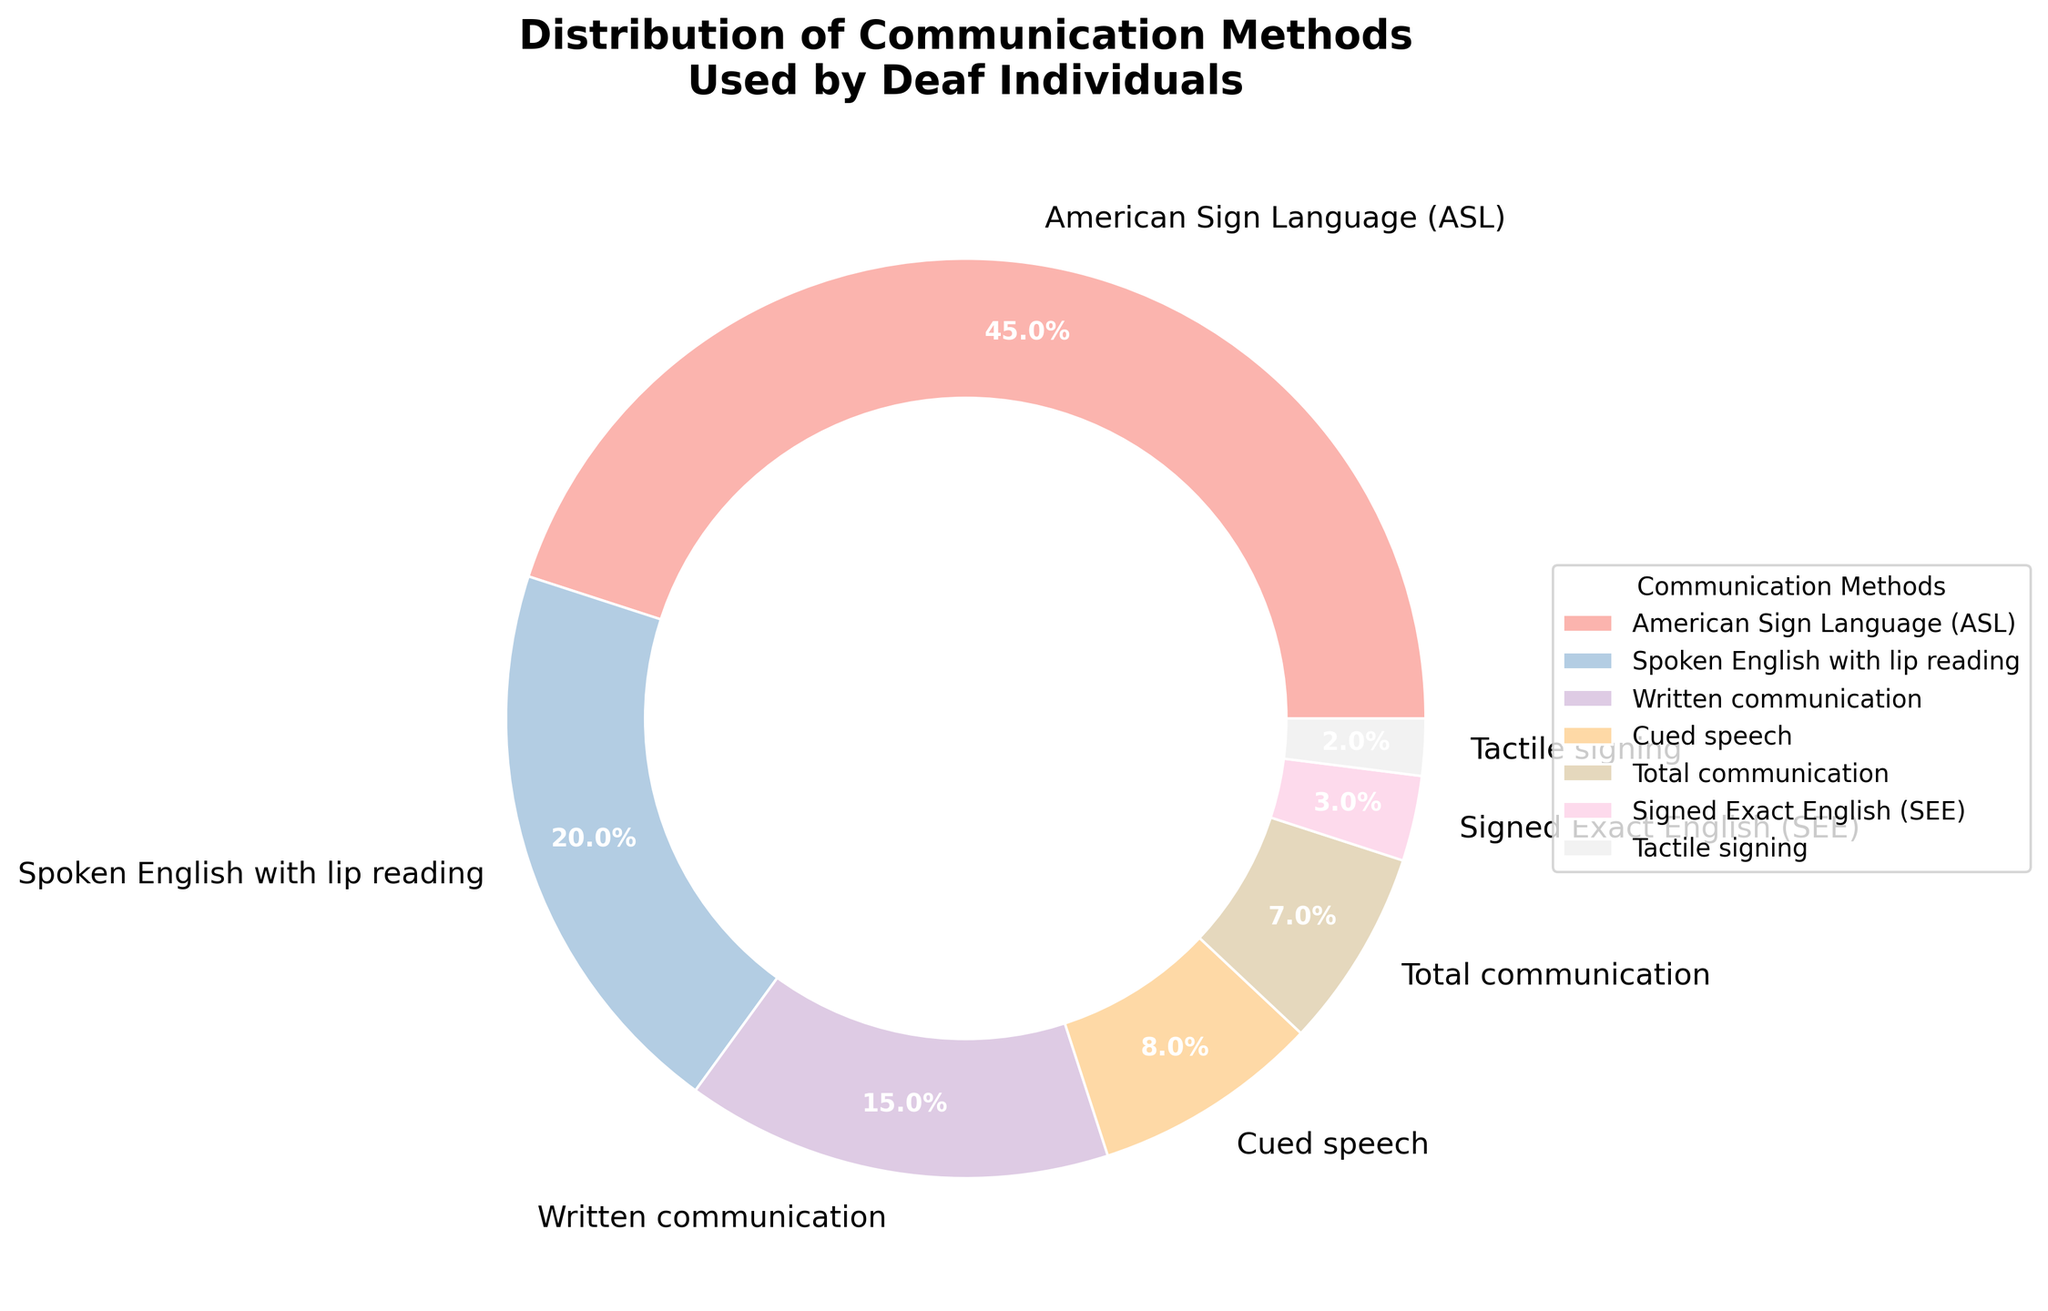Which communication method is used by the highest percentage of deaf individuals? According to the pie chart, the largest segment represents American Sign Language (ASL) with 45%.
Answer: American Sign Language (ASL) What is the combined percentage of individuals using written communication and cued speech? The percentages for written communication and cued speech are 15% and 8%, respectively. Adding these together: 15% + 8% = 23%.
Answer: 23% How does the percentage of individuals using total communication compare to those using cued speech? From the pie chart, total communication is used by 7% of individuals, whereas cued speech is used by 8%. By comparison, 7% is less than 8%.
Answer: Total communication is less than cued speech What percentage of deaf individuals use tactile signing? The pie chart shows a segment labeled tactile signing with a percentage of 2%. Therefore, 2% of the individuals use tactile signing.
Answer: 2% Among the methods listed, which two have the smallest percentages of use? The pie chart segments for Signed Exact English (SEE) and tactile signing are the smallest, with percentages of 3% and 2%, respectively.
Answer: Signed Exact English (SEE) and tactile signing What is the difference in percentage between individuals using spoken English with lip reading and those using total communication? Spoken English with lip reading is used by 20% of individuals, and total communication is used by 7%. The difference is 20% - 7% = 13%.
Answer: 13% If you were to group the methods into those labeled under 10% and those labeled over 10%, what percentage would each group represent? Adding those under 10%: cued speech (8%), total communication (7%), SEE (3%), tactile signing (2%) gives 8% + 7% + 3% + 2% = 20%. Adding those over 10%: ASL (45%), spoken English with lip reading (20%), written communication (15%) gives 45% + 20% + 15% = 80%.
Answer: Under 10%: 20%, Over 10%: 80% 